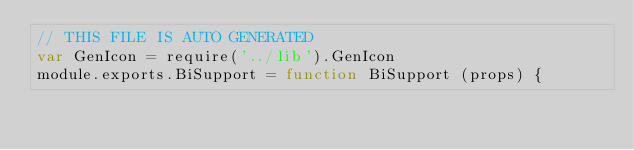Convert code to text. <code><loc_0><loc_0><loc_500><loc_500><_JavaScript_>// THIS FILE IS AUTO GENERATED
var GenIcon = require('../lib').GenIcon
module.exports.BiSupport = function BiSupport (props) {</code> 